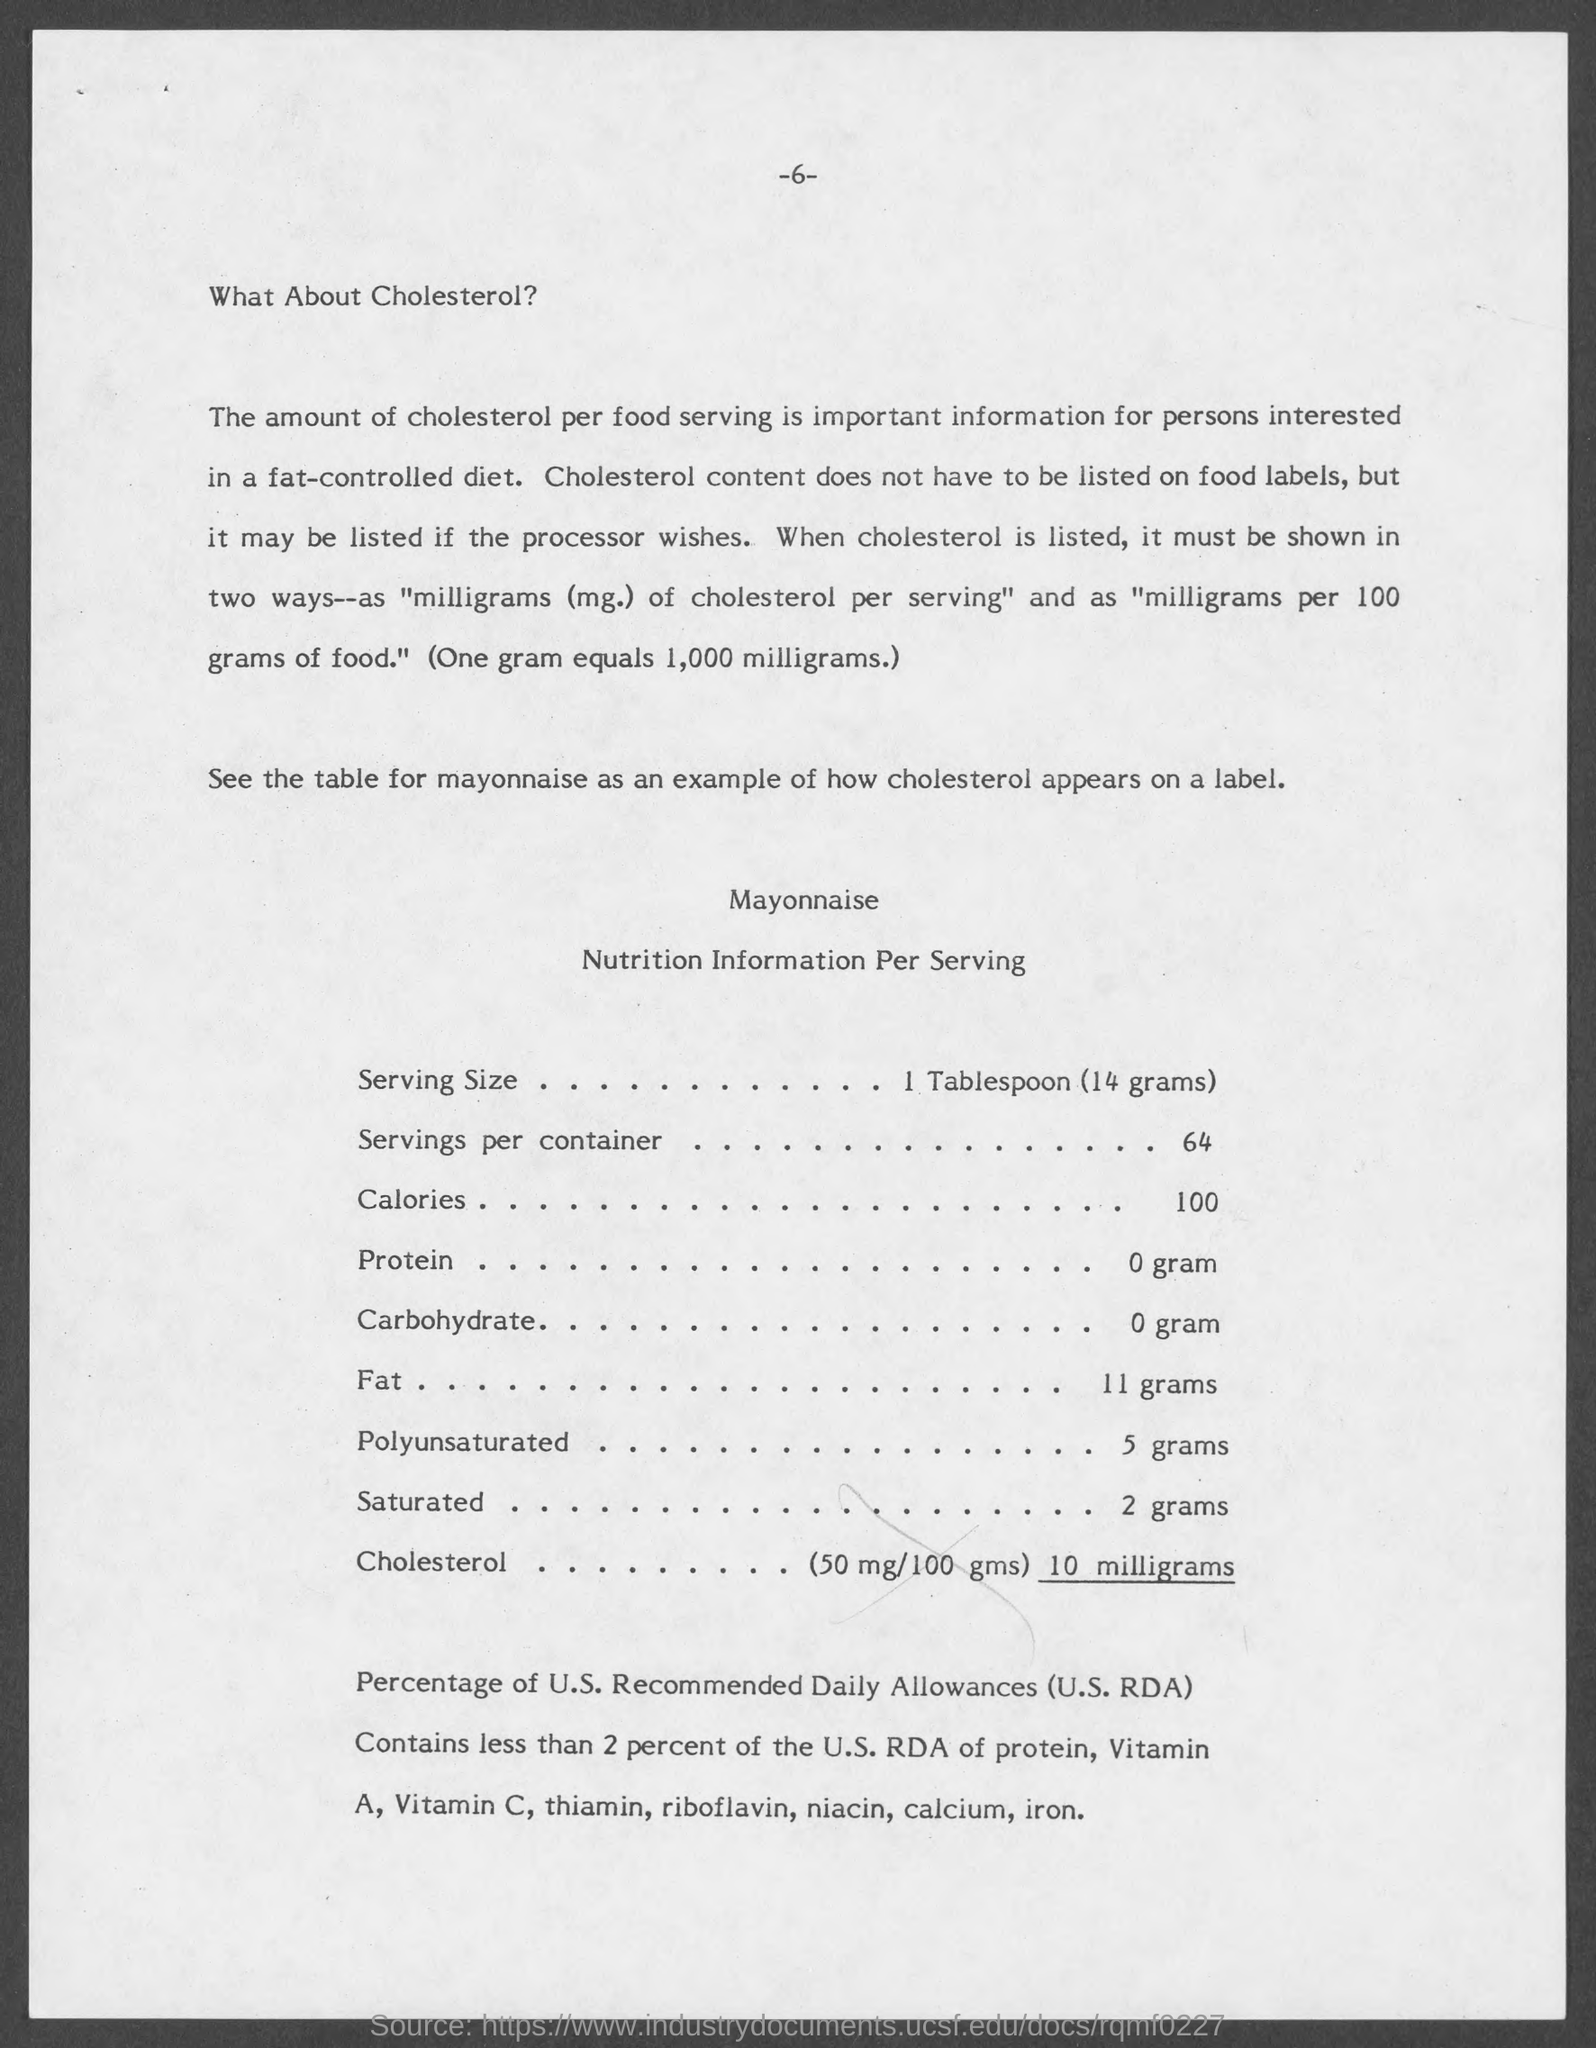What information is important for people intrested in fat-controlled diet ?
Your answer should be very brief. The amount of cholesterol per food serving. How much milligrams does one gram equals to ?
Make the answer very short. 1,000. What is the number written at the centre on the top of the page ?
Your answer should be compact. 6. What is the serving size mentioned in the table ?
Your answer should be compact. 1 tablespoon (14 grams). 